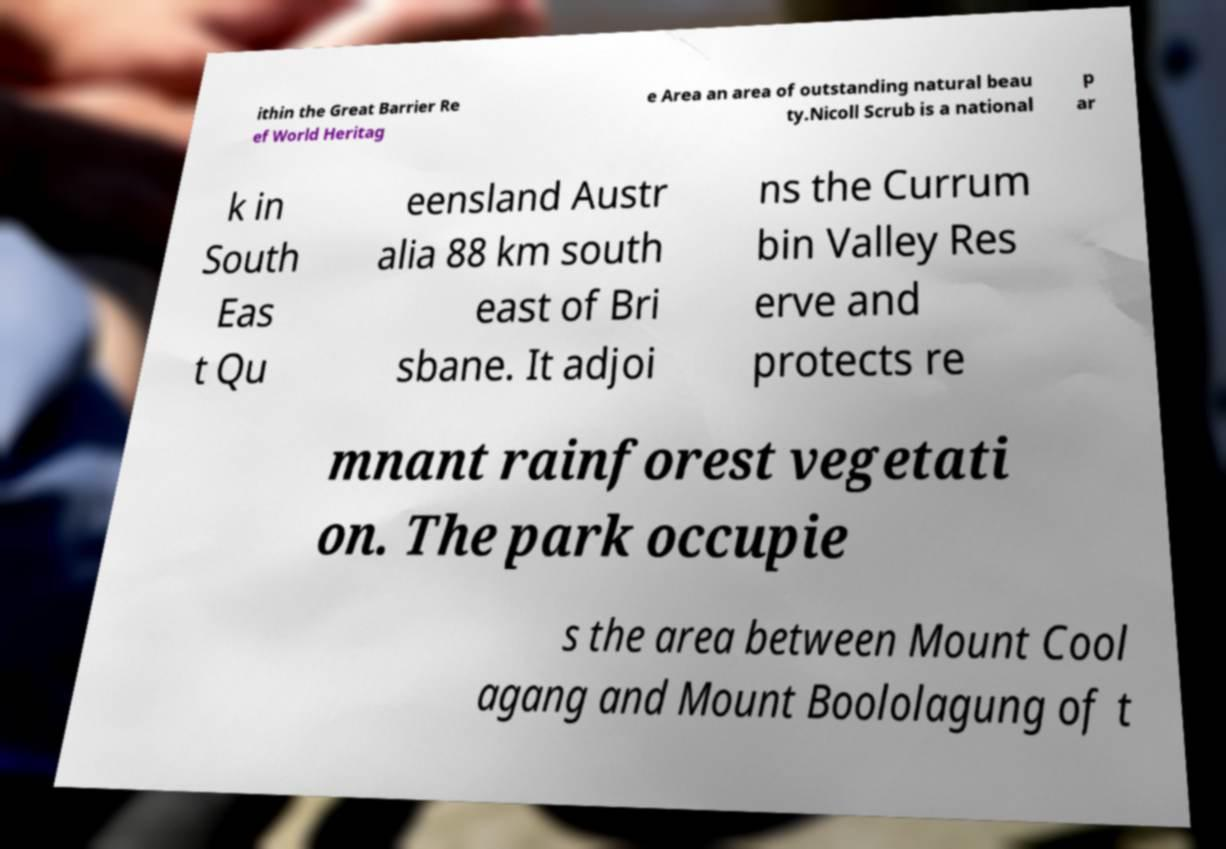What messages or text are displayed in this image? I need them in a readable, typed format. ithin the Great Barrier Re ef World Heritag e Area an area of outstanding natural beau ty.Nicoll Scrub is a national p ar k in South Eas t Qu eensland Austr alia 88 km south east of Bri sbane. It adjoi ns the Currum bin Valley Res erve and protects re mnant rainforest vegetati on. The park occupie s the area between Mount Cool agang and Mount Boololagung of t 